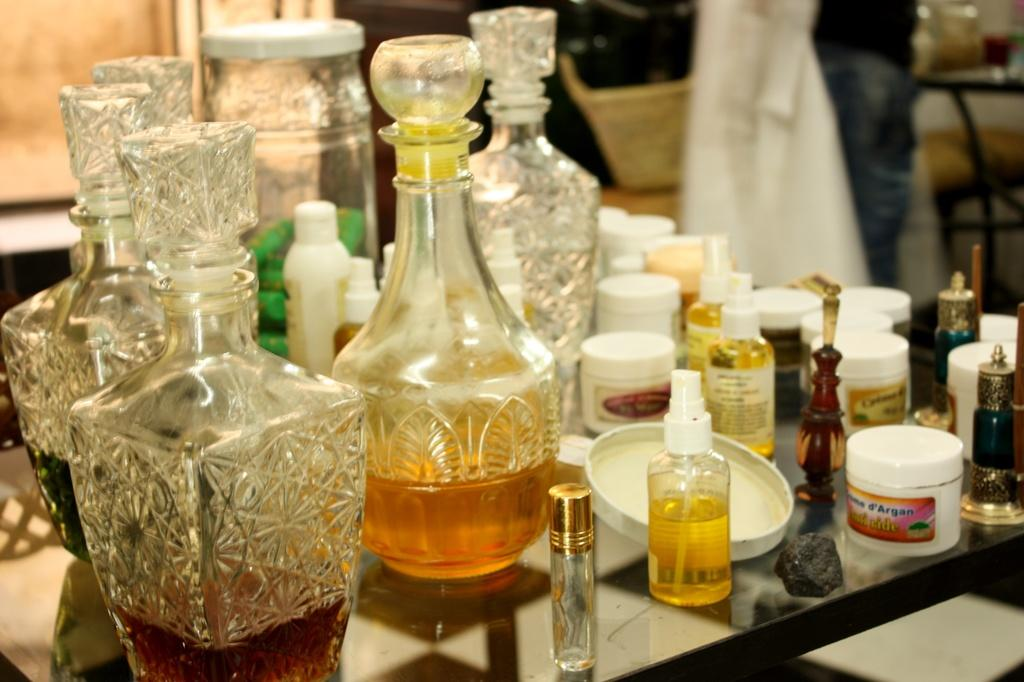Provide a one-sentence caption for the provided image. A table full of toiletries and decanters with a tub that says Argan on it. 